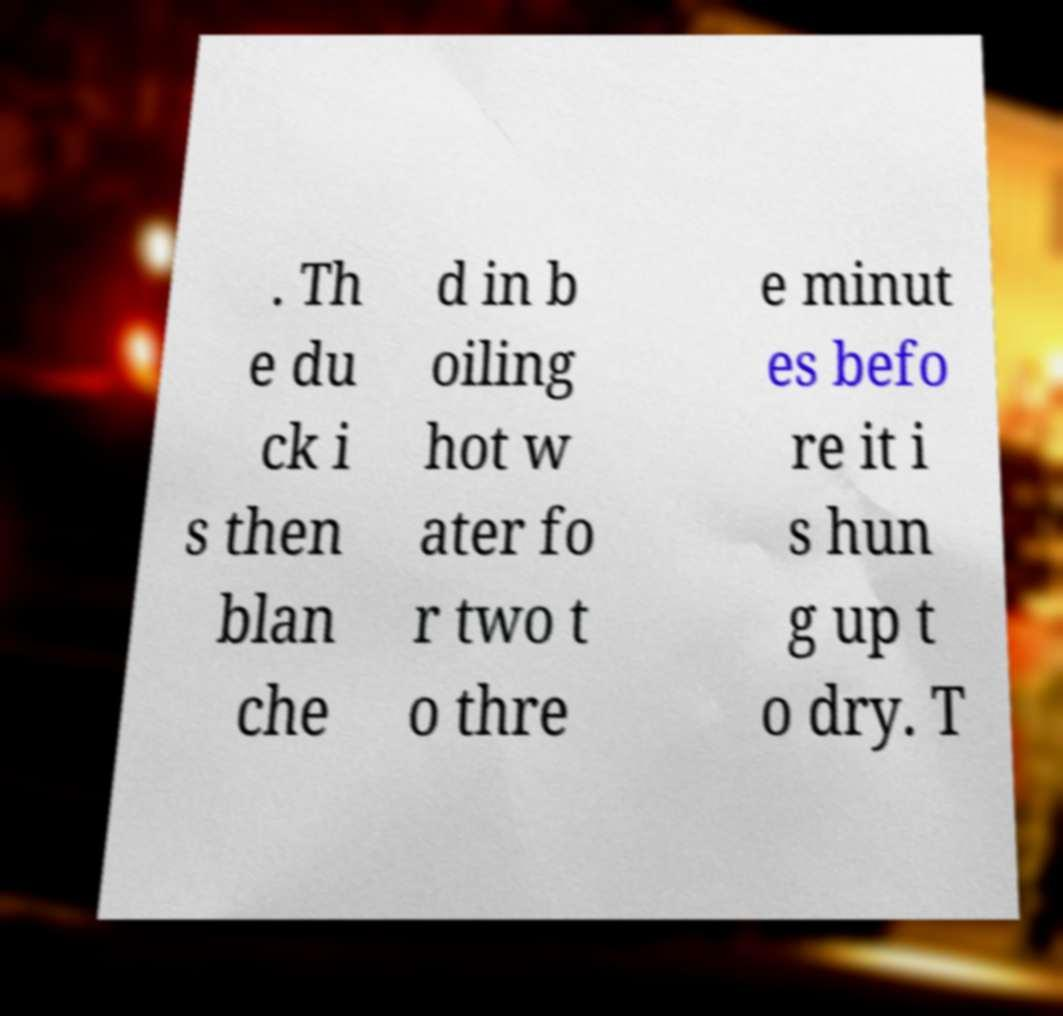For documentation purposes, I need the text within this image transcribed. Could you provide that? . Th e du ck i s then blan che d in b oiling hot w ater fo r two t o thre e minut es befo re it i s hun g up t o dry. T 